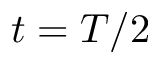<formula> <loc_0><loc_0><loc_500><loc_500>t = T / 2</formula> 